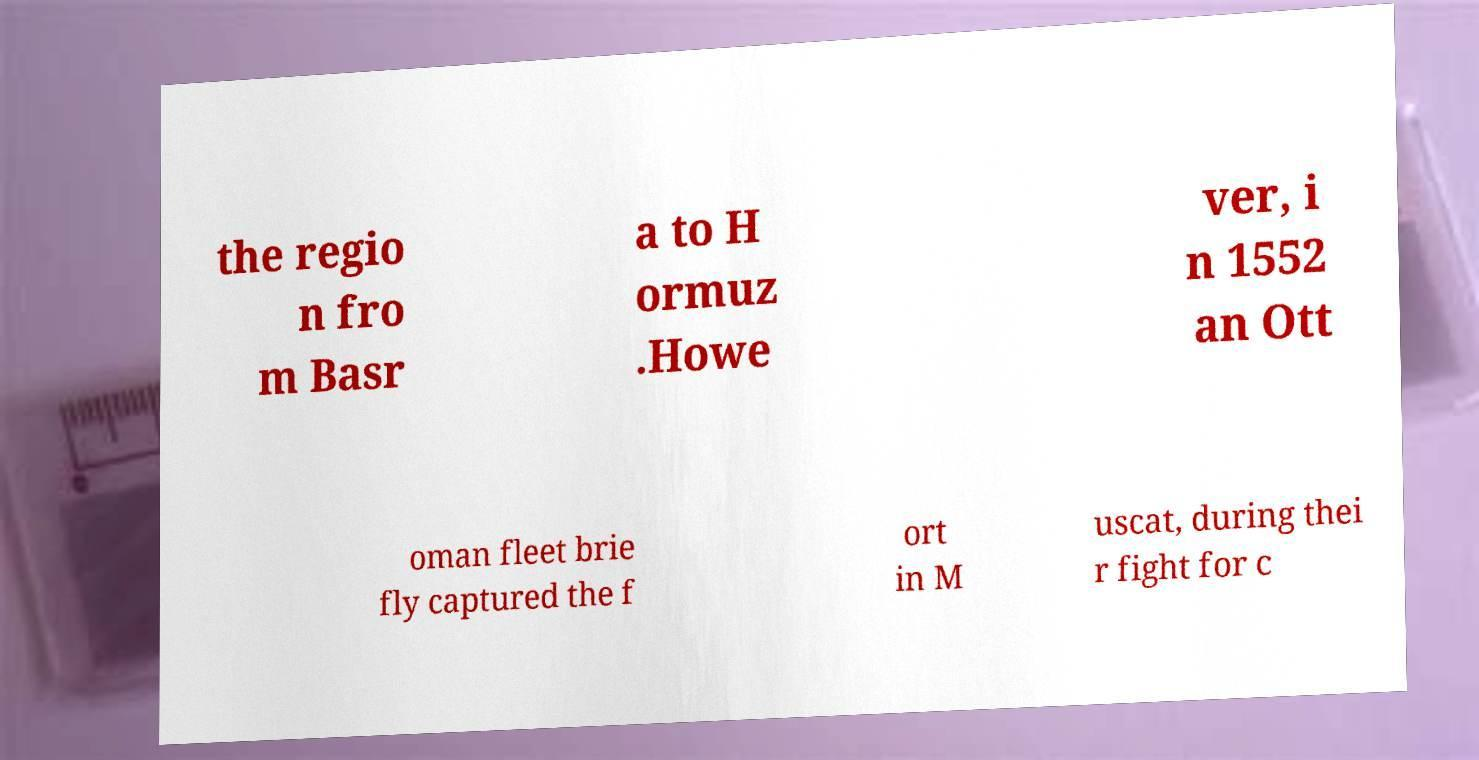Could you extract and type out the text from this image? the regio n fro m Basr a to H ormuz .Howe ver, i n 1552 an Ott oman fleet brie fly captured the f ort in M uscat, during thei r fight for c 